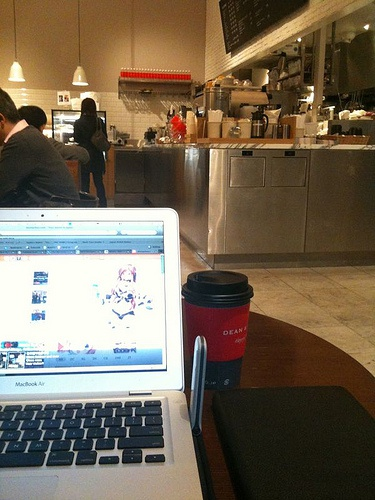Describe the objects in this image and their specific colors. I can see laptop in olive, white, darkgray, black, and lightblue tones, dining table in olive, black, maroon, and gray tones, cup in olive, black, maroon, gray, and lightgray tones, people in olive, black, maroon, and brown tones, and people in olive, black, maroon, and gray tones in this image. 